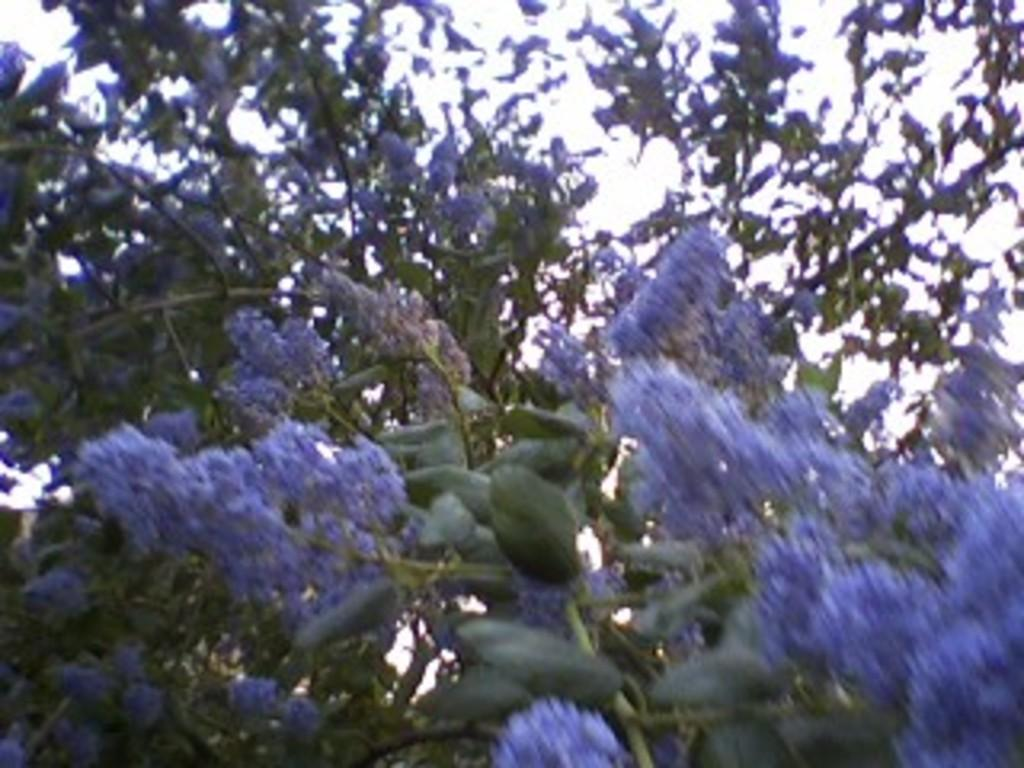What is present in the image? There is a tree in the image. What can be observed about the tree? The tree has flowers. Can you describe the quality of the image? The image is blurred. What type of payment is being made in the image? There is no payment being made in the image; it features a tree with flowers. What part of the sea is visible in the image? There is no sea present in the image; it features a tree with flowers. 